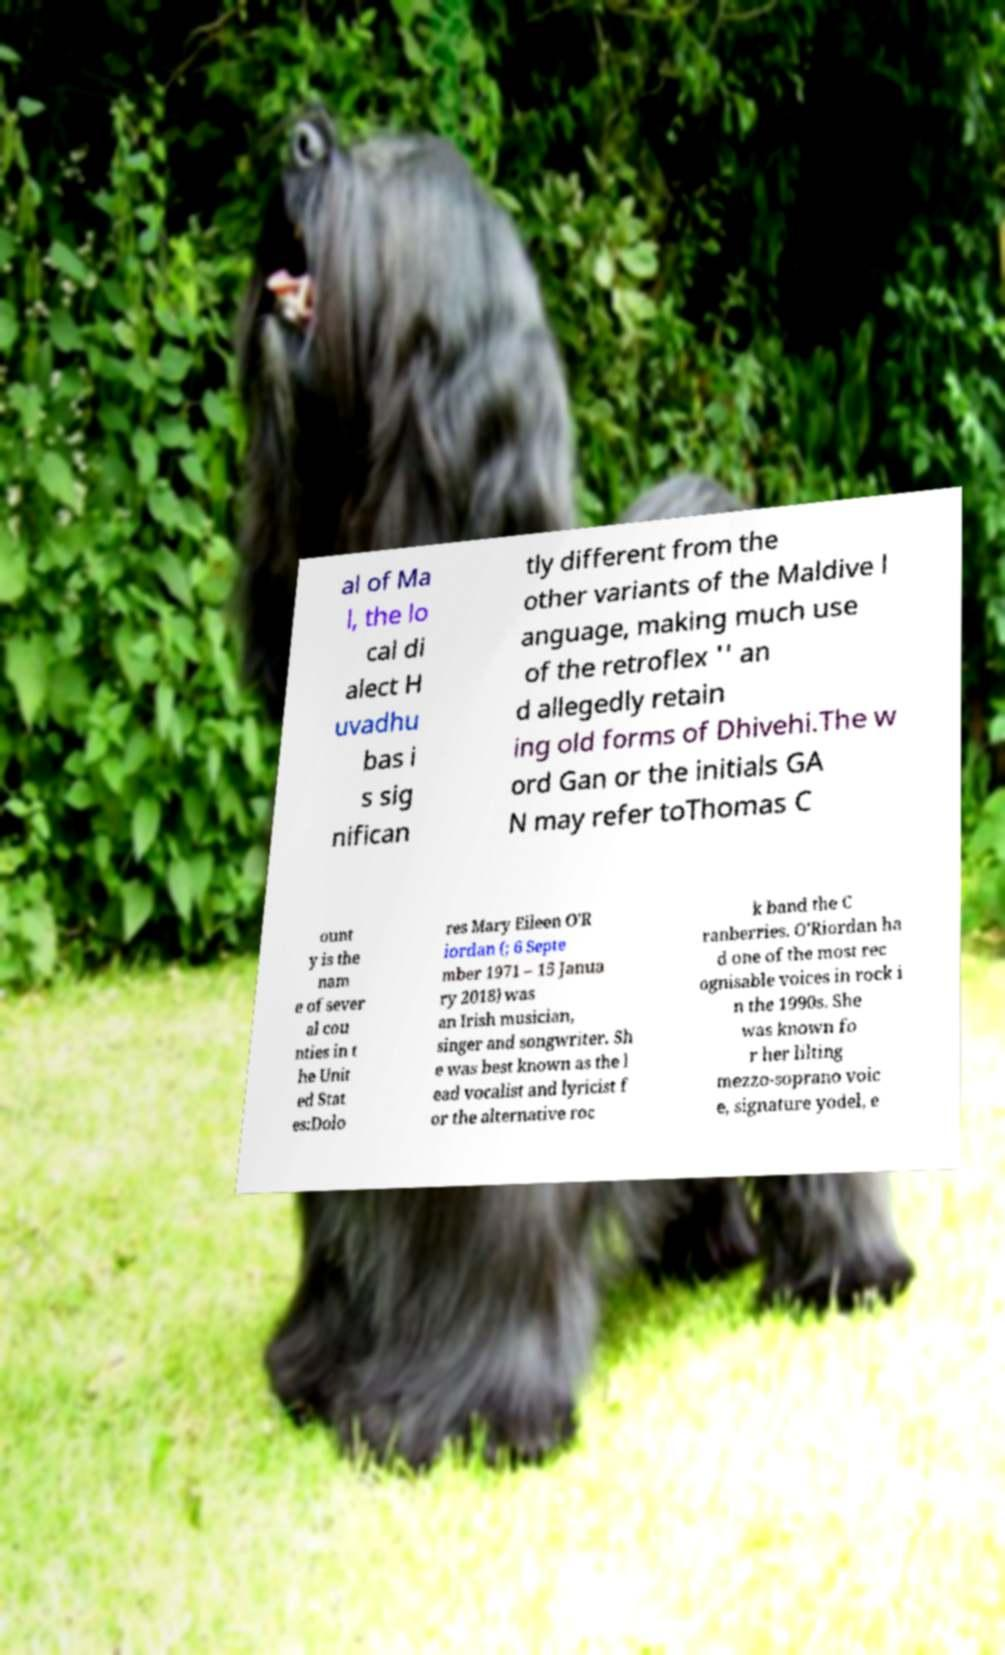Can you accurately transcribe the text from the provided image for me? al of Ma l, the lo cal di alect H uvadhu bas i s sig nifican tly different from the other variants of the Maldive l anguage, making much use of the retroflex '' an d allegedly retain ing old forms of Dhivehi.The w ord Gan or the initials GA N may refer toThomas C ount y is the nam e of sever al cou nties in t he Unit ed Stat es:Dolo res Mary Eileen O'R iordan (; 6 Septe mber 1971 – 15 Janua ry 2018) was an Irish musician, singer and songwriter. Sh e was best known as the l ead vocalist and lyricist f or the alternative roc k band the C ranberries. O'Riordan ha d one of the most rec ognisable voices in rock i n the 1990s. She was known fo r her lilting mezzo-soprano voic e, signature yodel, e 